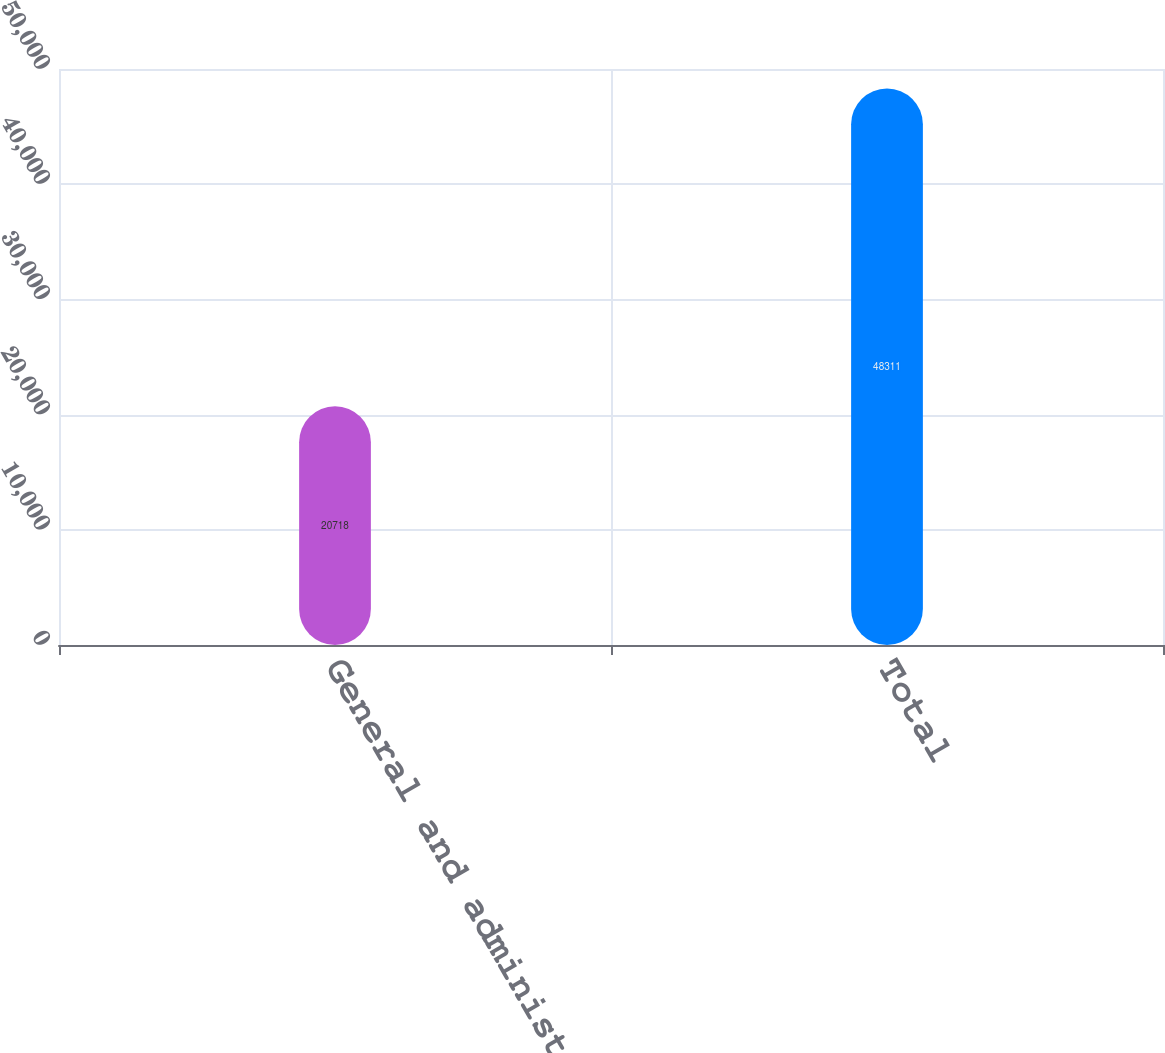Convert chart. <chart><loc_0><loc_0><loc_500><loc_500><bar_chart><fcel>General and administrative<fcel>Total<nl><fcel>20718<fcel>48311<nl></chart> 